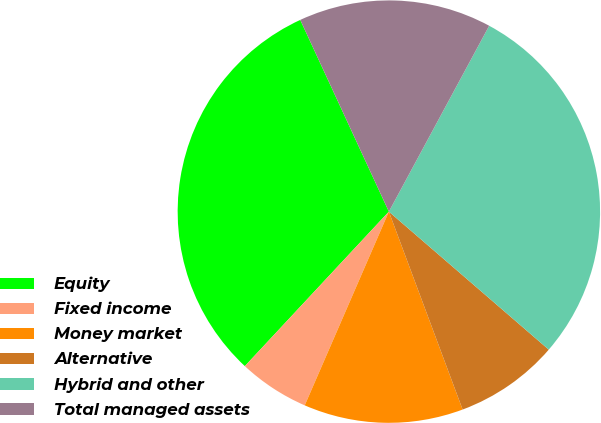Convert chart. <chart><loc_0><loc_0><loc_500><loc_500><pie_chart><fcel>Equity<fcel>Fixed income<fcel>Money market<fcel>Alternative<fcel>Hybrid and other<fcel>Total managed assets<nl><fcel>31.17%<fcel>5.42%<fcel>12.2%<fcel>7.99%<fcel>28.46%<fcel>14.77%<nl></chart> 